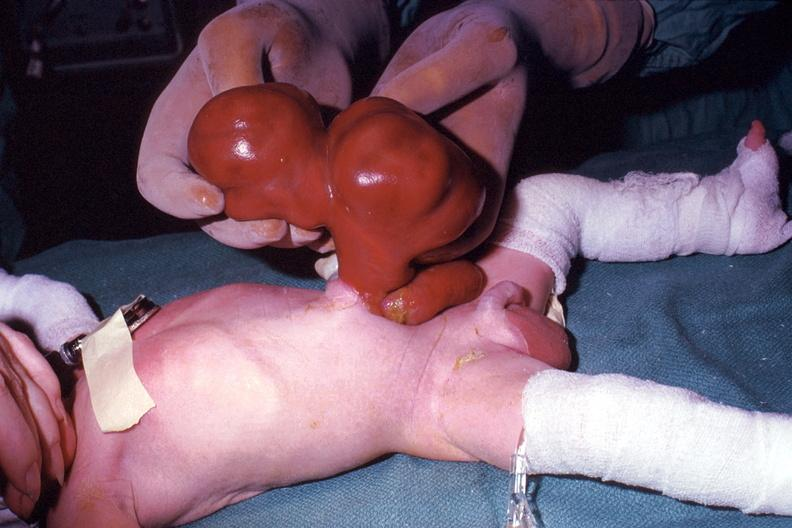how is a photo taken during life lesion?
Answer the question using a single word or phrase. Large 